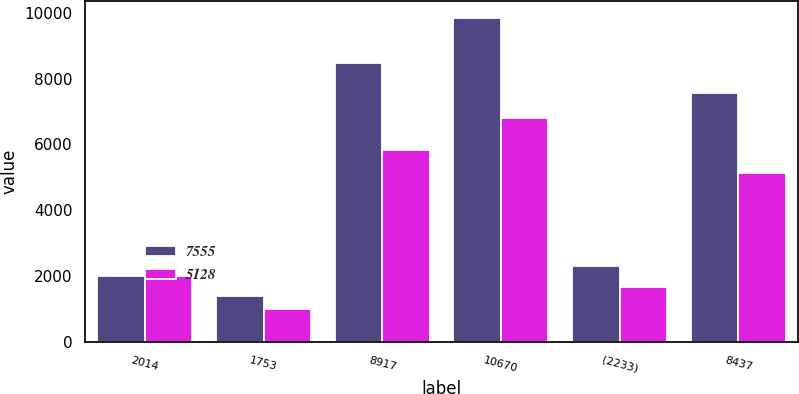<chart> <loc_0><loc_0><loc_500><loc_500><stacked_bar_chart><ecel><fcel>2014<fcel>1753<fcel>8917<fcel>10670<fcel>(2233)<fcel>8437<nl><fcel>7555<fcel>2013<fcel>1380<fcel>8471<fcel>9851<fcel>2296<fcel>7555<nl><fcel>5128<fcel>2012<fcel>991<fcel>5819<fcel>6810<fcel>1682<fcel>5128<nl></chart> 